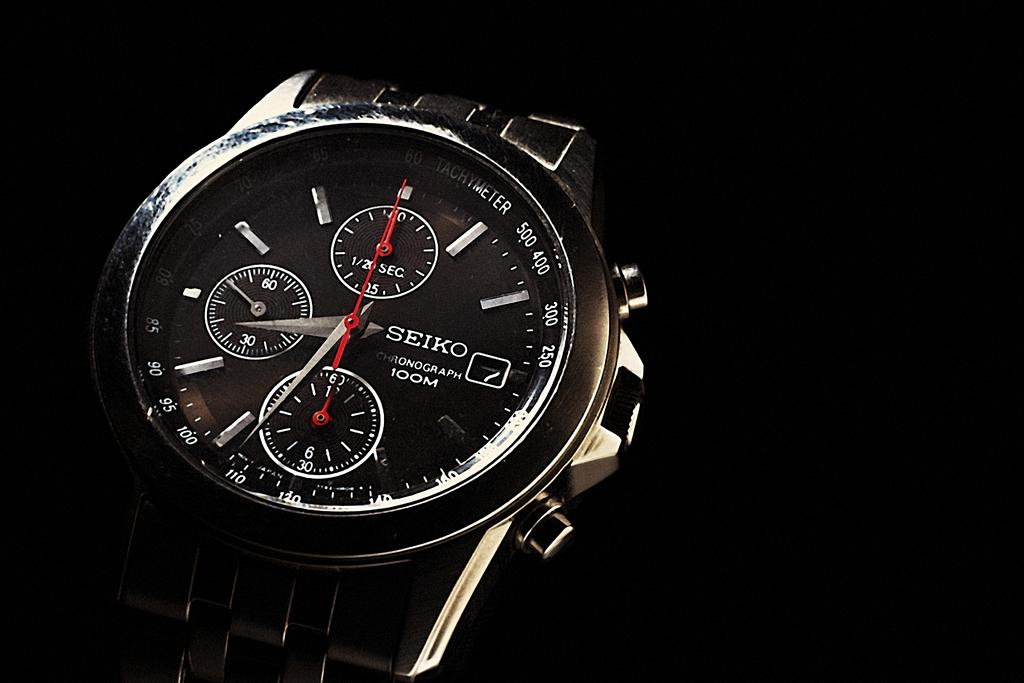<image>
Write a terse but informative summary of the picture. A Seiko wristwatch has a 100M chronograph as one of its features. 